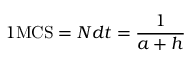<formula> <loc_0><loc_0><loc_500><loc_500>1 M C S = N d t = \frac { 1 } { a + h }</formula> 